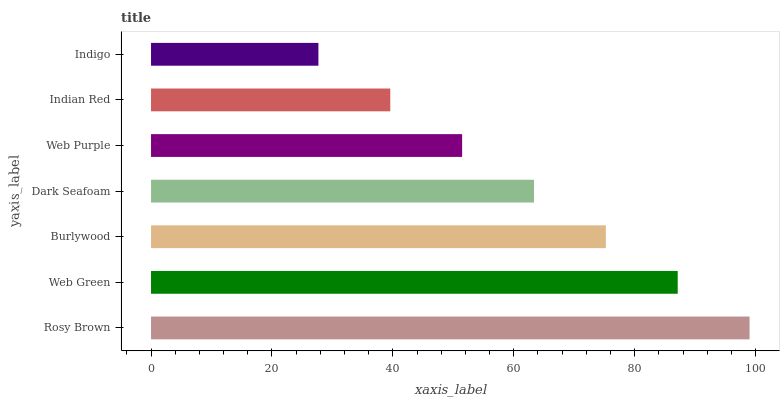Is Indigo the minimum?
Answer yes or no. Yes. Is Rosy Brown the maximum?
Answer yes or no. Yes. Is Web Green the minimum?
Answer yes or no. No. Is Web Green the maximum?
Answer yes or no. No. Is Rosy Brown greater than Web Green?
Answer yes or no. Yes. Is Web Green less than Rosy Brown?
Answer yes or no. Yes. Is Web Green greater than Rosy Brown?
Answer yes or no. No. Is Rosy Brown less than Web Green?
Answer yes or no. No. Is Dark Seafoam the high median?
Answer yes or no. Yes. Is Dark Seafoam the low median?
Answer yes or no. Yes. Is Web Purple the high median?
Answer yes or no. No. Is Indian Red the low median?
Answer yes or no. No. 